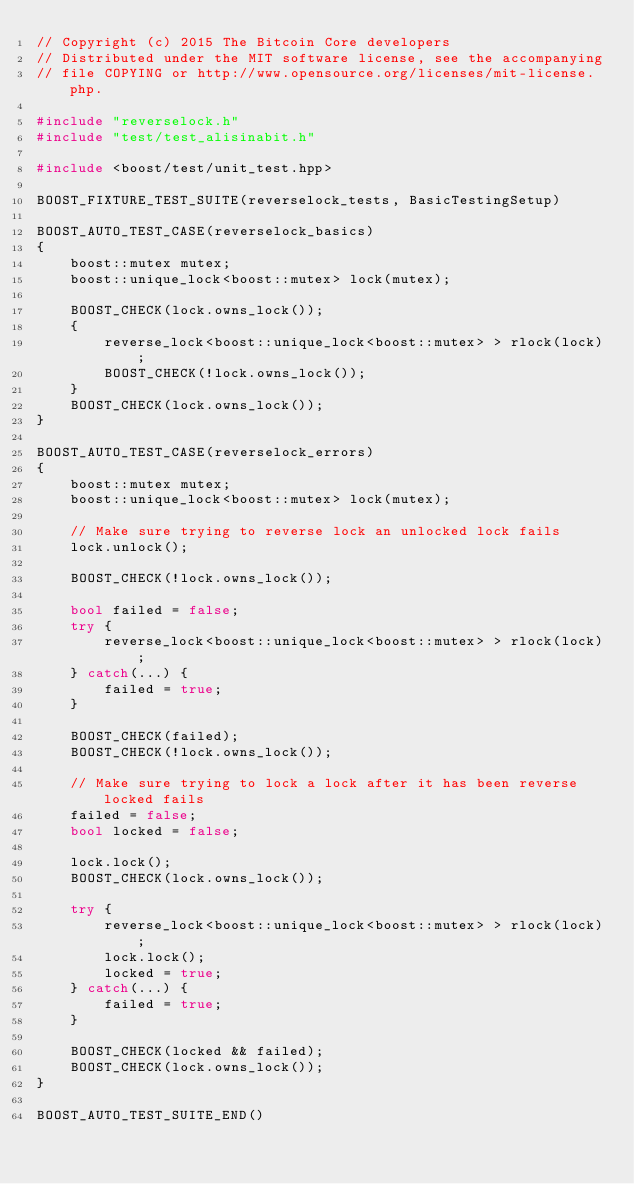Convert code to text. <code><loc_0><loc_0><loc_500><loc_500><_C++_>// Copyright (c) 2015 The Bitcoin Core developers
// Distributed under the MIT software license, see the accompanying
// file COPYING or http://www.opensource.org/licenses/mit-license.php.

#include "reverselock.h"
#include "test/test_alisinabit.h"

#include <boost/test/unit_test.hpp>

BOOST_FIXTURE_TEST_SUITE(reverselock_tests, BasicTestingSetup)

BOOST_AUTO_TEST_CASE(reverselock_basics)
{
    boost::mutex mutex;
    boost::unique_lock<boost::mutex> lock(mutex);

    BOOST_CHECK(lock.owns_lock());
    {
        reverse_lock<boost::unique_lock<boost::mutex> > rlock(lock);
        BOOST_CHECK(!lock.owns_lock());
    }
    BOOST_CHECK(lock.owns_lock());
}

BOOST_AUTO_TEST_CASE(reverselock_errors)
{
    boost::mutex mutex;
    boost::unique_lock<boost::mutex> lock(mutex);

    // Make sure trying to reverse lock an unlocked lock fails
    lock.unlock();

    BOOST_CHECK(!lock.owns_lock());

    bool failed = false;
    try {
        reverse_lock<boost::unique_lock<boost::mutex> > rlock(lock);
    } catch(...) {
        failed = true;
    }

    BOOST_CHECK(failed);
    BOOST_CHECK(!lock.owns_lock());

    // Make sure trying to lock a lock after it has been reverse locked fails
    failed = false;
    bool locked = false;

    lock.lock();
    BOOST_CHECK(lock.owns_lock());

    try {
        reverse_lock<boost::unique_lock<boost::mutex> > rlock(lock);
        lock.lock();
        locked = true;
    } catch(...) {
        failed = true;
    }

    BOOST_CHECK(locked && failed);
    BOOST_CHECK(lock.owns_lock());
}

BOOST_AUTO_TEST_SUITE_END()
</code> 